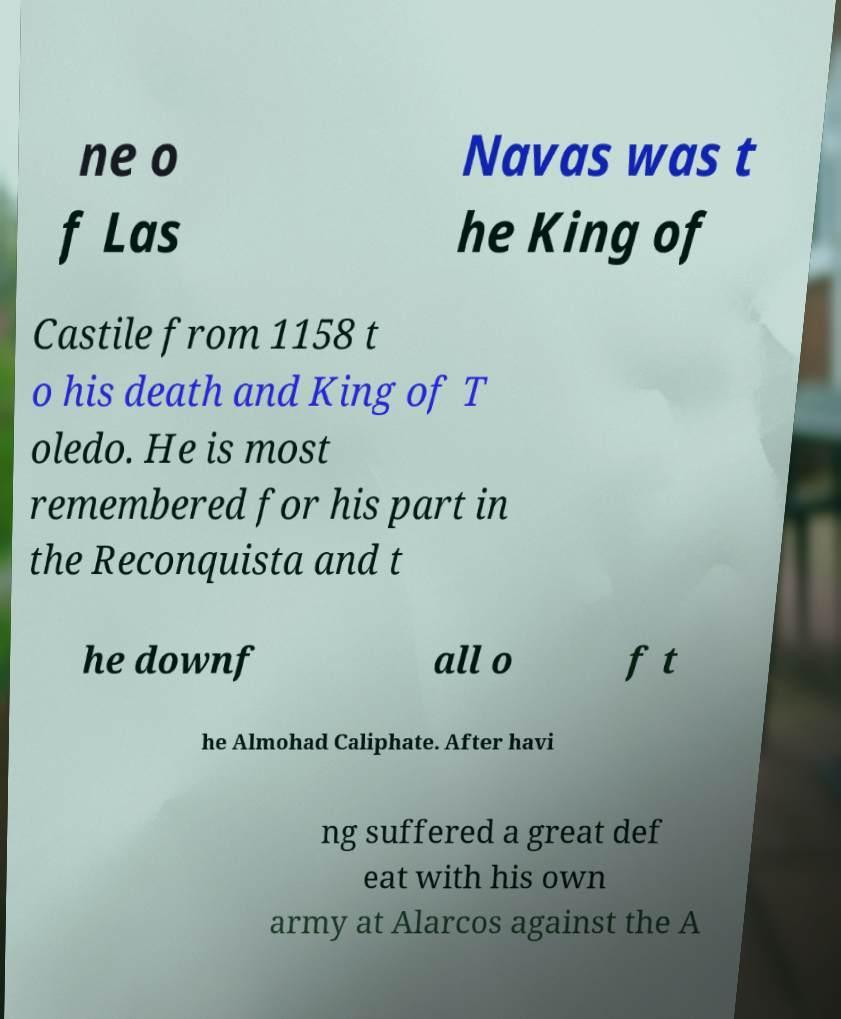There's text embedded in this image that I need extracted. Can you transcribe it verbatim? ne o f Las Navas was t he King of Castile from 1158 t o his death and King of T oledo. He is most remembered for his part in the Reconquista and t he downf all o f t he Almohad Caliphate. After havi ng suffered a great def eat with his own army at Alarcos against the A 